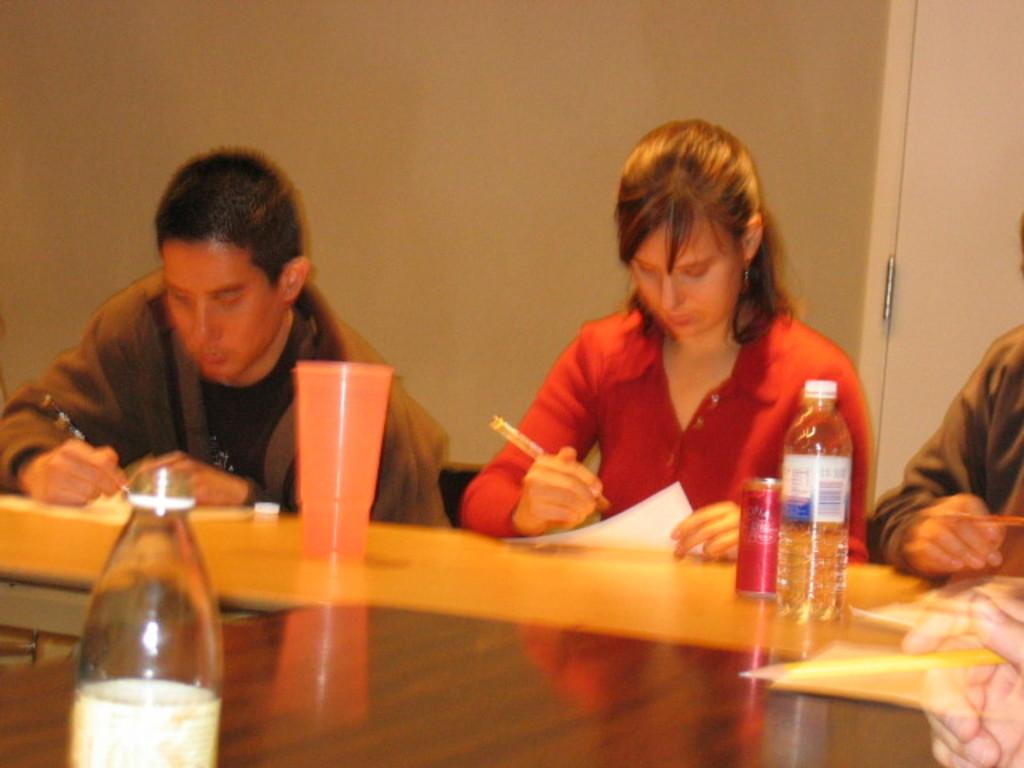What are the people in the image doing? The people in the image are sitting on chairs. What is present in the image besides the people? There is a table in the image. What items can be seen on the table? There are bottles and glasses on the table. What type of lawyer is present in the image? There is no lawyer present in the image. How many snakes can be seen slithering on the table in the image? There are no snakes present in the image; only bottles and glasses are on the table. 